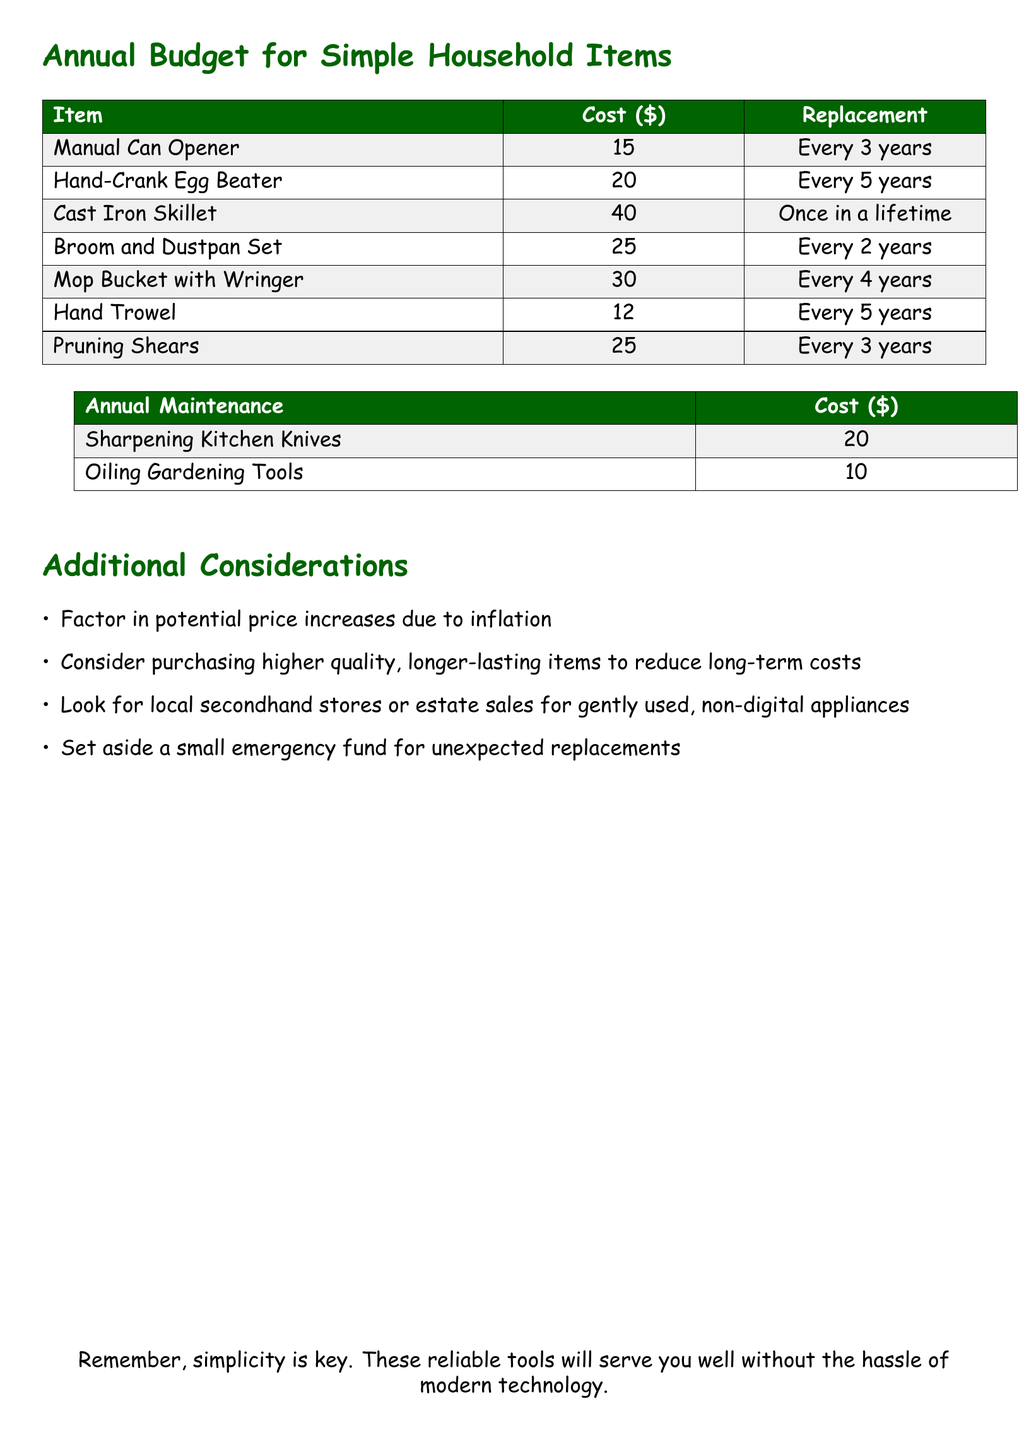What is the cost of a manual can opener? The cost of a manual can opener is explicitly listed in the document.
Answer: 15 How often should the broom and dustpan set be replaced? The document specifies the replacement frequency for each item, including the broom and dustpan set.
Answer: Every 2 years What is the annual maintenance cost for oiling gardening tools? The document contains a list of annual maintenance costs, including the cost for oiling gardening tools.
Answer: 10 Which household item has a one-time replacement cost? By reviewing the replacement information in the document, we can identify items that do not require regular replacement.
Answer: Cast Iron Skillet What is the total cost for sharpening kitchen knives and oiling gardening tools? The total combines both annual maintenance costs listed in the document: $20 + $10.
Answer: 30 How frequently need pruning shears be replaced? The document provides details on how often various tools, including pruning shears, need to be replaced.
Answer: Every 3 years What is suggested for unexpected replacements? The document includes a section with additional considerations that suggest planning for unexpected costs.
Answer: Emergency fund What type of items are recommended to consider purchasing? The document advises on item purchases in its additional considerations section.
Answer: Higher quality, longer-lasting items 